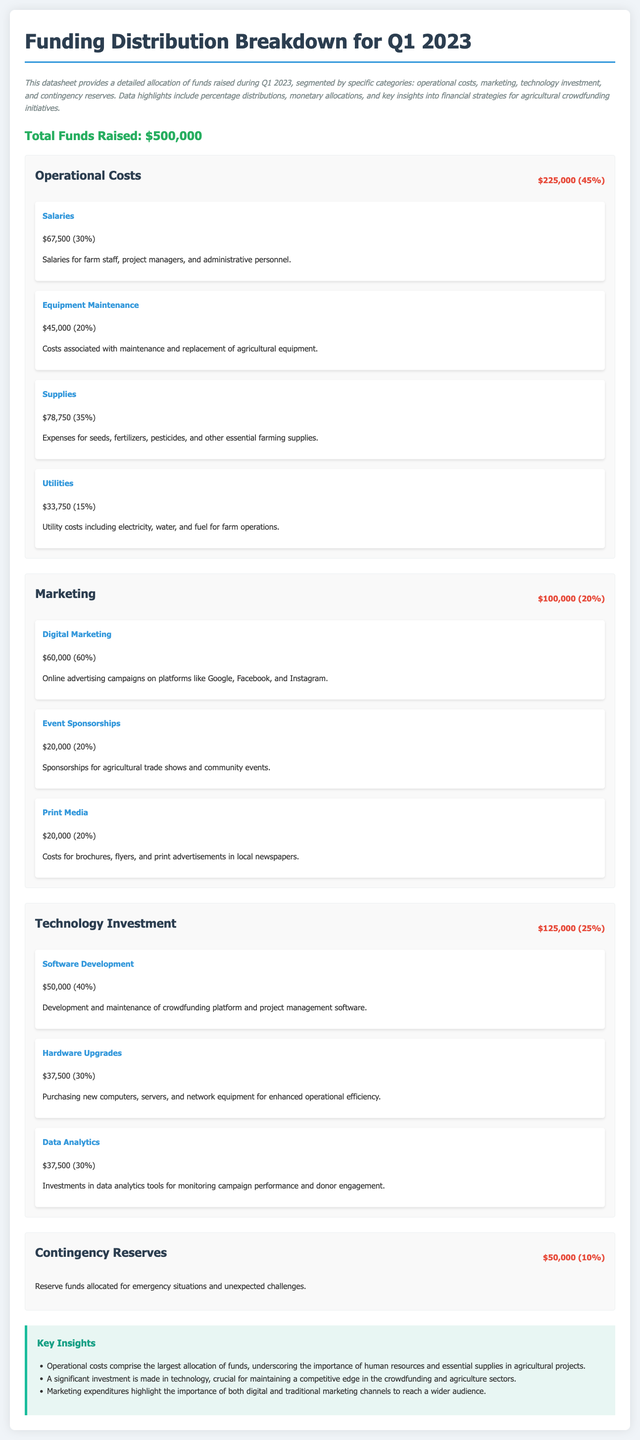What is the total funds raised? The total funds raised is stated at the beginning of the document, which is $500,000.
Answer: $500,000 What percentage of the funds is allocated to operational costs? The operational costs allocation is detailed, which shows it accounts for 45% of the total funds raised.
Answer: 45% How much money is designated for marketing? The marketing section indicates that $100,000 is allocated for this purpose.
Answer: $100,000 What is the amount reserved for contingency? The contingency reserves section specifies that $50,000 is allocated for unexpected challenges.
Answer: $50,000 Which category has the largest allocation of funds? By comparing the amounts of the categories, it is evident that operational costs have the largest allocation.
Answer: Operational Costs How much is allocated for hardware upgrades? The technology investment section breaks down its components, indicating that $37,500 is allocated for hardware upgrades.
Answer: $37,500 What percentage of the marketing budget is spent on digital marketing? The marketing breakdown shows that 60% of the marketing budget is spent on digital marketing.
Answer: 60% What is the purpose of the contingency reserves? The document describes the purpose of contingency reserves as funds for emergency situations and unexpected challenges.
Answer: Emergency situations What key insight highlights the importance of technology investment? One of the key insights emphasizes the significance of technology investment for maintaining a competitive edge.
Answer: Competitive edge 